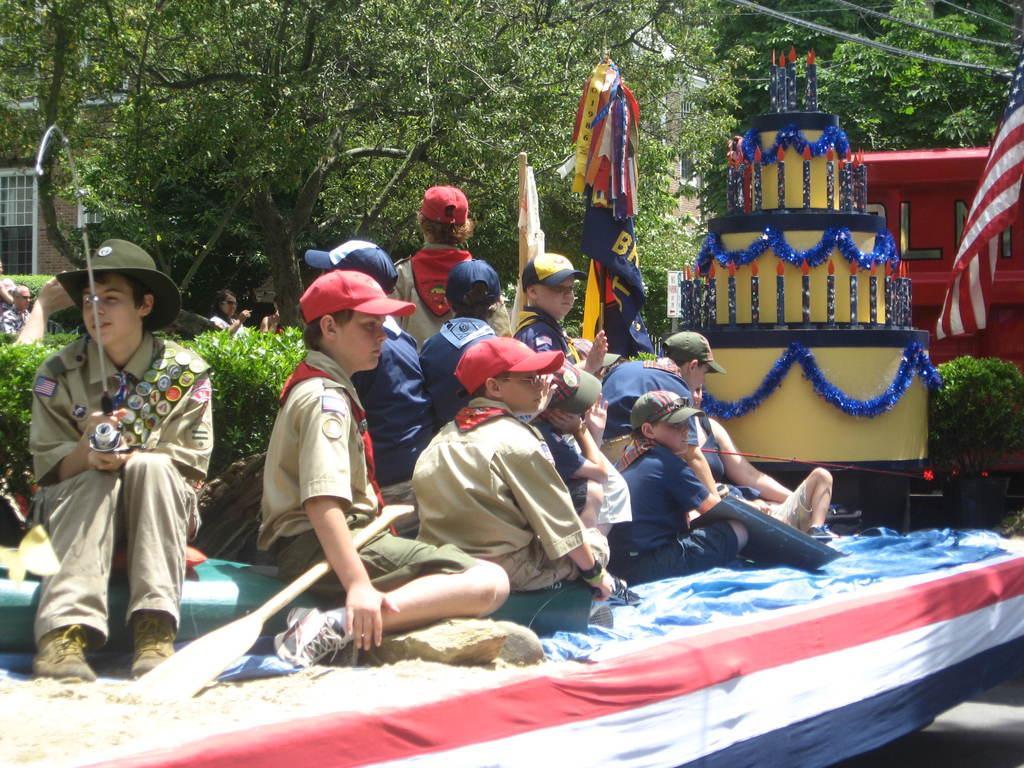Can you describe this image briefly? In this image we can see a group of people sitting, in front of them there is an object looks like a cake with candles and some decorative items attached to it, there are flags and trees in the background. 